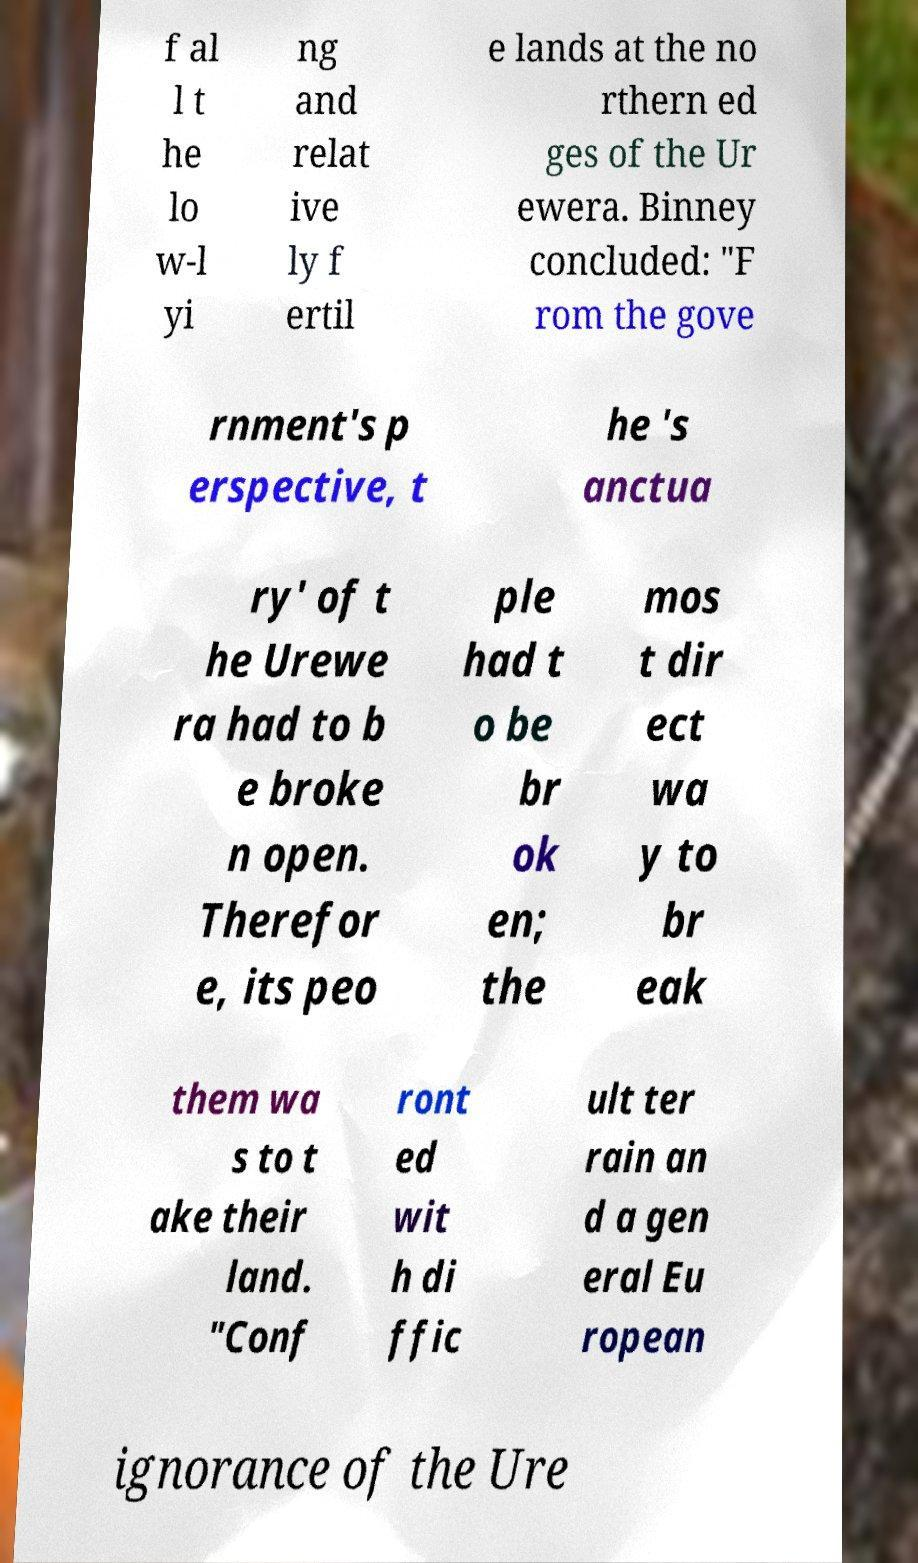Please identify and transcribe the text found in this image. f al l t he lo w-l yi ng and relat ive ly f ertil e lands at the no rthern ed ges of the Ur ewera. Binney concluded: "F rom the gove rnment's p erspective, t he 's anctua ry' of t he Urewe ra had to b e broke n open. Therefor e, its peo ple had t o be br ok en; the mos t dir ect wa y to br eak them wa s to t ake their land. "Conf ront ed wit h di ffic ult ter rain an d a gen eral Eu ropean ignorance of the Ure 